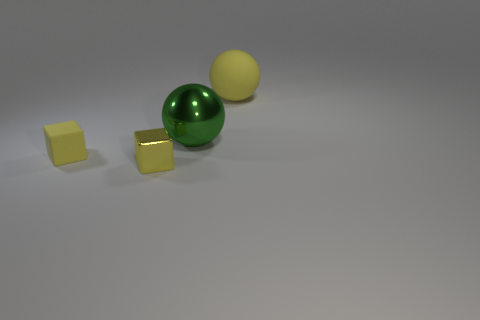Are there any tiny yellow blocks that have the same material as the yellow ball?
Your response must be concise. Yes. Is the number of large shiny balls that are behind the big green shiny object greater than the number of tiny yellow blocks behind the small rubber object?
Make the answer very short. No. Do the rubber block and the green metal object have the same size?
Ensure brevity in your answer.  No. There is a matte object behind the thing that is to the left of the metal cube; what is its color?
Provide a short and direct response. Yellow. What is the color of the metallic ball?
Give a very brief answer. Green. Are there any big blocks of the same color as the small metal object?
Your answer should be compact. No. Does the large ball in front of the matte sphere have the same color as the small rubber object?
Offer a very short reply. No. What number of things are metallic things that are to the right of the yellow metallic block or small brown balls?
Ensure brevity in your answer.  1. There is a small metallic cube; are there any matte balls to the left of it?
Your answer should be compact. No. What is the material of the other cube that is the same color as the rubber block?
Provide a succinct answer. Metal. 